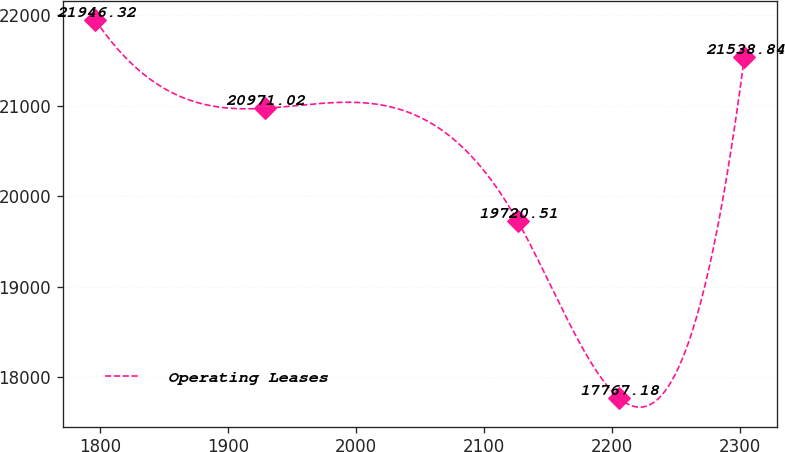Convert chart to OTSL. <chart><loc_0><loc_0><loc_500><loc_500><line_chart><ecel><fcel>Operating Leases<nl><fcel>1796.39<fcel>21946.3<nl><fcel>1928.94<fcel>20971<nl><fcel>2126.46<fcel>19720.5<nl><fcel>2205.48<fcel>17767.2<nl><fcel>2303.5<fcel>21538.8<nl></chart> 